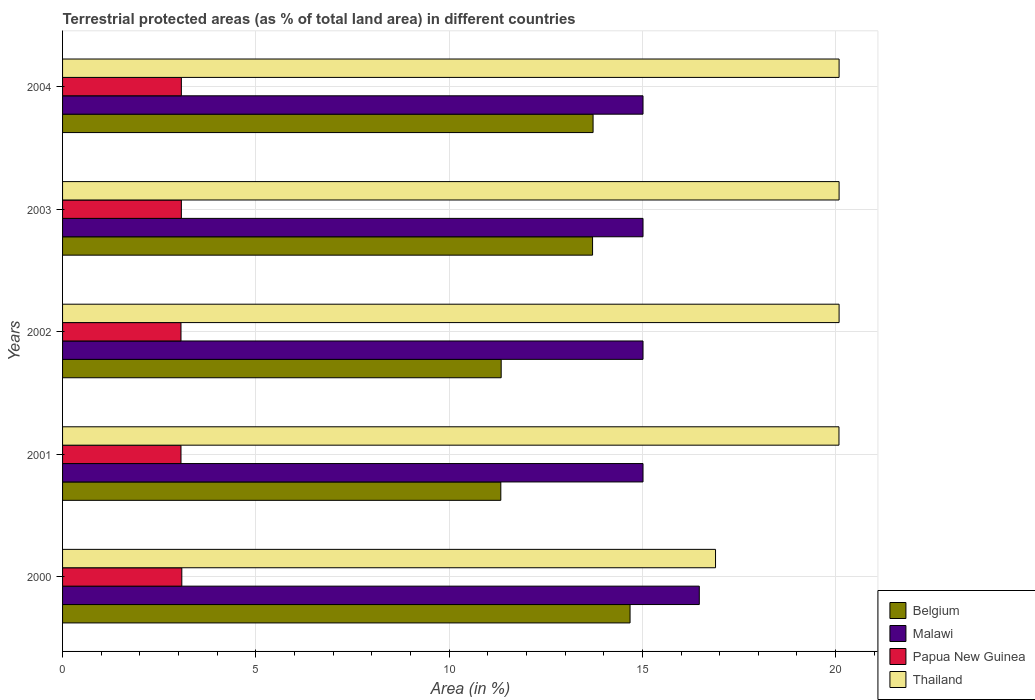How many bars are there on the 2nd tick from the bottom?
Your answer should be compact. 4. What is the label of the 2nd group of bars from the top?
Your answer should be very brief. 2003. In how many cases, is the number of bars for a given year not equal to the number of legend labels?
Keep it short and to the point. 0. What is the percentage of terrestrial protected land in Belgium in 2002?
Provide a succinct answer. 11.35. Across all years, what is the maximum percentage of terrestrial protected land in Thailand?
Your answer should be compact. 20.09. Across all years, what is the minimum percentage of terrestrial protected land in Papua New Guinea?
Give a very brief answer. 3.06. In which year was the percentage of terrestrial protected land in Thailand maximum?
Your answer should be compact. 2003. In which year was the percentage of terrestrial protected land in Papua New Guinea minimum?
Offer a terse response. 2001. What is the total percentage of terrestrial protected land in Papua New Guinea in the graph?
Provide a succinct answer. 15.36. What is the difference between the percentage of terrestrial protected land in Belgium in 2001 and that in 2003?
Provide a short and direct response. -2.37. What is the difference between the percentage of terrestrial protected land in Papua New Guinea in 2004 and the percentage of terrestrial protected land in Thailand in 2003?
Keep it short and to the point. -17.02. What is the average percentage of terrestrial protected land in Malawi per year?
Your response must be concise. 15.31. In the year 2004, what is the difference between the percentage of terrestrial protected land in Belgium and percentage of terrestrial protected land in Malawi?
Your answer should be compact. -1.29. In how many years, is the percentage of terrestrial protected land in Papua New Guinea greater than 10 %?
Keep it short and to the point. 0. What is the ratio of the percentage of terrestrial protected land in Malawi in 2000 to that in 2004?
Keep it short and to the point. 1.1. Is the percentage of terrestrial protected land in Thailand in 2001 less than that in 2003?
Provide a succinct answer. Yes. What is the difference between the highest and the second highest percentage of terrestrial protected land in Belgium?
Ensure brevity in your answer.  0.96. What is the difference between the highest and the lowest percentage of terrestrial protected land in Malawi?
Your answer should be compact. 1.46. Is it the case that in every year, the sum of the percentage of terrestrial protected land in Papua New Guinea and percentage of terrestrial protected land in Belgium is greater than the sum of percentage of terrestrial protected land in Thailand and percentage of terrestrial protected land in Malawi?
Provide a short and direct response. No. What does the 1st bar from the bottom in 2001 represents?
Give a very brief answer. Belgium. Are all the bars in the graph horizontal?
Your answer should be very brief. Yes. How many years are there in the graph?
Provide a succinct answer. 5. What is the difference between two consecutive major ticks on the X-axis?
Offer a very short reply. 5. Where does the legend appear in the graph?
Make the answer very short. Bottom right. How many legend labels are there?
Offer a terse response. 4. What is the title of the graph?
Give a very brief answer. Terrestrial protected areas (as % of total land area) in different countries. What is the label or title of the X-axis?
Your response must be concise. Area (in %). What is the Area (in %) in Belgium in 2000?
Keep it short and to the point. 14.68. What is the Area (in %) in Malawi in 2000?
Ensure brevity in your answer.  16.47. What is the Area (in %) in Papua New Guinea in 2000?
Keep it short and to the point. 3.09. What is the Area (in %) of Thailand in 2000?
Make the answer very short. 16.89. What is the Area (in %) of Belgium in 2001?
Ensure brevity in your answer.  11.34. What is the Area (in %) in Malawi in 2001?
Give a very brief answer. 15.02. What is the Area (in %) in Papua New Guinea in 2001?
Offer a terse response. 3.06. What is the Area (in %) of Thailand in 2001?
Keep it short and to the point. 20.09. What is the Area (in %) in Belgium in 2002?
Provide a succinct answer. 11.35. What is the Area (in %) of Malawi in 2002?
Offer a very short reply. 15.02. What is the Area (in %) of Papua New Guinea in 2002?
Your answer should be very brief. 3.06. What is the Area (in %) of Thailand in 2002?
Offer a very short reply. 20.09. What is the Area (in %) of Belgium in 2003?
Give a very brief answer. 13.71. What is the Area (in %) of Malawi in 2003?
Make the answer very short. 15.02. What is the Area (in %) of Papua New Guinea in 2003?
Keep it short and to the point. 3.07. What is the Area (in %) of Thailand in 2003?
Provide a succinct answer. 20.09. What is the Area (in %) in Belgium in 2004?
Your answer should be very brief. 13.73. What is the Area (in %) of Malawi in 2004?
Keep it short and to the point. 15.02. What is the Area (in %) in Papua New Guinea in 2004?
Make the answer very short. 3.07. What is the Area (in %) in Thailand in 2004?
Ensure brevity in your answer.  20.09. Across all years, what is the maximum Area (in %) of Belgium?
Offer a very short reply. 14.68. Across all years, what is the maximum Area (in %) in Malawi?
Ensure brevity in your answer.  16.47. Across all years, what is the maximum Area (in %) in Papua New Guinea?
Ensure brevity in your answer.  3.09. Across all years, what is the maximum Area (in %) of Thailand?
Ensure brevity in your answer.  20.09. Across all years, what is the minimum Area (in %) of Belgium?
Offer a very short reply. 11.34. Across all years, what is the minimum Area (in %) in Malawi?
Make the answer very short. 15.02. Across all years, what is the minimum Area (in %) in Papua New Guinea?
Offer a terse response. 3.06. Across all years, what is the minimum Area (in %) of Thailand?
Your answer should be compact. 16.89. What is the total Area (in %) of Belgium in the graph?
Provide a succinct answer. 64.81. What is the total Area (in %) of Malawi in the graph?
Make the answer very short. 76.54. What is the total Area (in %) of Papua New Guinea in the graph?
Ensure brevity in your answer.  15.36. What is the total Area (in %) of Thailand in the graph?
Make the answer very short. 97.25. What is the difference between the Area (in %) of Belgium in 2000 and that in 2001?
Keep it short and to the point. 3.34. What is the difference between the Area (in %) of Malawi in 2000 and that in 2001?
Give a very brief answer. 1.46. What is the difference between the Area (in %) of Papua New Guinea in 2000 and that in 2001?
Your answer should be very brief. 0.02. What is the difference between the Area (in %) of Thailand in 2000 and that in 2001?
Offer a very short reply. -3.19. What is the difference between the Area (in %) in Belgium in 2000 and that in 2002?
Give a very brief answer. 3.33. What is the difference between the Area (in %) in Malawi in 2000 and that in 2002?
Make the answer very short. 1.46. What is the difference between the Area (in %) of Papua New Guinea in 2000 and that in 2002?
Give a very brief answer. 0.02. What is the difference between the Area (in %) of Thailand in 2000 and that in 2002?
Give a very brief answer. -3.2. What is the difference between the Area (in %) in Belgium in 2000 and that in 2003?
Make the answer very short. 0.97. What is the difference between the Area (in %) in Malawi in 2000 and that in 2003?
Your response must be concise. 1.46. What is the difference between the Area (in %) of Papua New Guinea in 2000 and that in 2003?
Give a very brief answer. 0.01. What is the difference between the Area (in %) of Thailand in 2000 and that in 2003?
Give a very brief answer. -3.2. What is the difference between the Area (in %) of Belgium in 2000 and that in 2004?
Your answer should be very brief. 0.96. What is the difference between the Area (in %) in Malawi in 2000 and that in 2004?
Keep it short and to the point. 1.46. What is the difference between the Area (in %) in Papua New Guinea in 2000 and that in 2004?
Give a very brief answer. 0.01. What is the difference between the Area (in %) in Thailand in 2000 and that in 2004?
Your answer should be compact. -3.2. What is the difference between the Area (in %) in Belgium in 2001 and that in 2002?
Your response must be concise. -0.01. What is the difference between the Area (in %) in Papua New Guinea in 2001 and that in 2002?
Provide a succinct answer. 0. What is the difference between the Area (in %) in Thailand in 2001 and that in 2002?
Your answer should be compact. -0. What is the difference between the Area (in %) in Belgium in 2001 and that in 2003?
Your answer should be compact. -2.37. What is the difference between the Area (in %) in Papua New Guinea in 2001 and that in 2003?
Give a very brief answer. -0.01. What is the difference between the Area (in %) in Thailand in 2001 and that in 2003?
Give a very brief answer. -0. What is the difference between the Area (in %) of Belgium in 2001 and that in 2004?
Offer a very short reply. -2.39. What is the difference between the Area (in %) of Papua New Guinea in 2001 and that in 2004?
Keep it short and to the point. -0.01. What is the difference between the Area (in %) in Thailand in 2001 and that in 2004?
Ensure brevity in your answer.  -0. What is the difference between the Area (in %) in Belgium in 2002 and that in 2003?
Give a very brief answer. -2.36. What is the difference between the Area (in %) in Malawi in 2002 and that in 2003?
Keep it short and to the point. 0. What is the difference between the Area (in %) in Papua New Guinea in 2002 and that in 2003?
Offer a very short reply. -0.01. What is the difference between the Area (in %) of Belgium in 2002 and that in 2004?
Provide a succinct answer. -2.38. What is the difference between the Area (in %) in Papua New Guinea in 2002 and that in 2004?
Offer a terse response. -0.01. What is the difference between the Area (in %) in Belgium in 2003 and that in 2004?
Your answer should be very brief. -0.01. What is the difference between the Area (in %) of Belgium in 2000 and the Area (in %) of Malawi in 2001?
Offer a terse response. -0.34. What is the difference between the Area (in %) in Belgium in 2000 and the Area (in %) in Papua New Guinea in 2001?
Your answer should be very brief. 11.62. What is the difference between the Area (in %) in Belgium in 2000 and the Area (in %) in Thailand in 2001?
Make the answer very short. -5.4. What is the difference between the Area (in %) of Malawi in 2000 and the Area (in %) of Papua New Guinea in 2001?
Ensure brevity in your answer.  13.41. What is the difference between the Area (in %) of Malawi in 2000 and the Area (in %) of Thailand in 2001?
Your answer should be very brief. -3.61. What is the difference between the Area (in %) of Papua New Guinea in 2000 and the Area (in %) of Thailand in 2001?
Give a very brief answer. -17. What is the difference between the Area (in %) of Belgium in 2000 and the Area (in %) of Malawi in 2002?
Make the answer very short. -0.34. What is the difference between the Area (in %) of Belgium in 2000 and the Area (in %) of Papua New Guinea in 2002?
Offer a terse response. 11.62. What is the difference between the Area (in %) of Belgium in 2000 and the Area (in %) of Thailand in 2002?
Make the answer very short. -5.41. What is the difference between the Area (in %) of Malawi in 2000 and the Area (in %) of Papua New Guinea in 2002?
Your answer should be compact. 13.41. What is the difference between the Area (in %) of Malawi in 2000 and the Area (in %) of Thailand in 2002?
Offer a very short reply. -3.62. What is the difference between the Area (in %) of Papua New Guinea in 2000 and the Area (in %) of Thailand in 2002?
Keep it short and to the point. -17. What is the difference between the Area (in %) of Belgium in 2000 and the Area (in %) of Malawi in 2003?
Your response must be concise. -0.34. What is the difference between the Area (in %) of Belgium in 2000 and the Area (in %) of Papua New Guinea in 2003?
Keep it short and to the point. 11.61. What is the difference between the Area (in %) of Belgium in 2000 and the Area (in %) of Thailand in 2003?
Offer a very short reply. -5.41. What is the difference between the Area (in %) in Malawi in 2000 and the Area (in %) in Thailand in 2003?
Provide a succinct answer. -3.62. What is the difference between the Area (in %) of Papua New Guinea in 2000 and the Area (in %) of Thailand in 2003?
Your answer should be compact. -17. What is the difference between the Area (in %) in Belgium in 2000 and the Area (in %) in Malawi in 2004?
Give a very brief answer. -0.34. What is the difference between the Area (in %) in Belgium in 2000 and the Area (in %) in Papua New Guinea in 2004?
Offer a very short reply. 11.61. What is the difference between the Area (in %) of Belgium in 2000 and the Area (in %) of Thailand in 2004?
Your answer should be very brief. -5.41. What is the difference between the Area (in %) in Malawi in 2000 and the Area (in %) in Papua New Guinea in 2004?
Your answer should be compact. 13.4. What is the difference between the Area (in %) in Malawi in 2000 and the Area (in %) in Thailand in 2004?
Your answer should be very brief. -3.62. What is the difference between the Area (in %) in Papua New Guinea in 2000 and the Area (in %) in Thailand in 2004?
Offer a very short reply. -17. What is the difference between the Area (in %) of Belgium in 2001 and the Area (in %) of Malawi in 2002?
Your answer should be very brief. -3.68. What is the difference between the Area (in %) of Belgium in 2001 and the Area (in %) of Papua New Guinea in 2002?
Ensure brevity in your answer.  8.27. What is the difference between the Area (in %) in Belgium in 2001 and the Area (in %) in Thailand in 2002?
Provide a succinct answer. -8.75. What is the difference between the Area (in %) of Malawi in 2001 and the Area (in %) of Papua New Guinea in 2002?
Keep it short and to the point. 11.95. What is the difference between the Area (in %) in Malawi in 2001 and the Area (in %) in Thailand in 2002?
Ensure brevity in your answer.  -5.07. What is the difference between the Area (in %) of Papua New Guinea in 2001 and the Area (in %) of Thailand in 2002?
Offer a terse response. -17.03. What is the difference between the Area (in %) in Belgium in 2001 and the Area (in %) in Malawi in 2003?
Provide a short and direct response. -3.68. What is the difference between the Area (in %) of Belgium in 2001 and the Area (in %) of Papua New Guinea in 2003?
Offer a terse response. 8.26. What is the difference between the Area (in %) in Belgium in 2001 and the Area (in %) in Thailand in 2003?
Provide a short and direct response. -8.75. What is the difference between the Area (in %) in Malawi in 2001 and the Area (in %) in Papua New Guinea in 2003?
Your answer should be compact. 11.94. What is the difference between the Area (in %) in Malawi in 2001 and the Area (in %) in Thailand in 2003?
Provide a succinct answer. -5.07. What is the difference between the Area (in %) of Papua New Guinea in 2001 and the Area (in %) of Thailand in 2003?
Ensure brevity in your answer.  -17.03. What is the difference between the Area (in %) in Belgium in 2001 and the Area (in %) in Malawi in 2004?
Provide a succinct answer. -3.68. What is the difference between the Area (in %) of Belgium in 2001 and the Area (in %) of Papua New Guinea in 2004?
Ensure brevity in your answer.  8.26. What is the difference between the Area (in %) in Belgium in 2001 and the Area (in %) in Thailand in 2004?
Your answer should be very brief. -8.75. What is the difference between the Area (in %) of Malawi in 2001 and the Area (in %) of Papua New Guinea in 2004?
Provide a short and direct response. 11.94. What is the difference between the Area (in %) of Malawi in 2001 and the Area (in %) of Thailand in 2004?
Your answer should be compact. -5.07. What is the difference between the Area (in %) of Papua New Guinea in 2001 and the Area (in %) of Thailand in 2004?
Your answer should be compact. -17.03. What is the difference between the Area (in %) in Belgium in 2002 and the Area (in %) in Malawi in 2003?
Provide a succinct answer. -3.67. What is the difference between the Area (in %) of Belgium in 2002 and the Area (in %) of Papua New Guinea in 2003?
Keep it short and to the point. 8.27. What is the difference between the Area (in %) in Belgium in 2002 and the Area (in %) in Thailand in 2003?
Your response must be concise. -8.74. What is the difference between the Area (in %) in Malawi in 2002 and the Area (in %) in Papua New Guinea in 2003?
Provide a short and direct response. 11.94. What is the difference between the Area (in %) in Malawi in 2002 and the Area (in %) in Thailand in 2003?
Keep it short and to the point. -5.07. What is the difference between the Area (in %) of Papua New Guinea in 2002 and the Area (in %) of Thailand in 2003?
Provide a short and direct response. -17.03. What is the difference between the Area (in %) of Belgium in 2002 and the Area (in %) of Malawi in 2004?
Offer a terse response. -3.67. What is the difference between the Area (in %) of Belgium in 2002 and the Area (in %) of Papua New Guinea in 2004?
Provide a short and direct response. 8.27. What is the difference between the Area (in %) of Belgium in 2002 and the Area (in %) of Thailand in 2004?
Give a very brief answer. -8.74. What is the difference between the Area (in %) in Malawi in 2002 and the Area (in %) in Papua New Guinea in 2004?
Your answer should be very brief. 11.94. What is the difference between the Area (in %) in Malawi in 2002 and the Area (in %) in Thailand in 2004?
Offer a terse response. -5.07. What is the difference between the Area (in %) in Papua New Guinea in 2002 and the Area (in %) in Thailand in 2004?
Provide a succinct answer. -17.03. What is the difference between the Area (in %) of Belgium in 2003 and the Area (in %) of Malawi in 2004?
Provide a succinct answer. -1.31. What is the difference between the Area (in %) in Belgium in 2003 and the Area (in %) in Papua New Guinea in 2004?
Provide a short and direct response. 10.64. What is the difference between the Area (in %) of Belgium in 2003 and the Area (in %) of Thailand in 2004?
Your answer should be very brief. -6.38. What is the difference between the Area (in %) in Malawi in 2003 and the Area (in %) in Papua New Guinea in 2004?
Make the answer very short. 11.94. What is the difference between the Area (in %) in Malawi in 2003 and the Area (in %) in Thailand in 2004?
Keep it short and to the point. -5.07. What is the difference between the Area (in %) of Papua New Guinea in 2003 and the Area (in %) of Thailand in 2004?
Make the answer very short. -17.02. What is the average Area (in %) of Belgium per year?
Provide a succinct answer. 12.96. What is the average Area (in %) of Malawi per year?
Provide a short and direct response. 15.31. What is the average Area (in %) in Papua New Guinea per year?
Make the answer very short. 3.07. What is the average Area (in %) of Thailand per year?
Provide a short and direct response. 19.45. In the year 2000, what is the difference between the Area (in %) of Belgium and Area (in %) of Malawi?
Your response must be concise. -1.79. In the year 2000, what is the difference between the Area (in %) of Belgium and Area (in %) of Papua New Guinea?
Your response must be concise. 11.6. In the year 2000, what is the difference between the Area (in %) in Belgium and Area (in %) in Thailand?
Provide a succinct answer. -2.21. In the year 2000, what is the difference between the Area (in %) in Malawi and Area (in %) in Papua New Guinea?
Offer a terse response. 13.39. In the year 2000, what is the difference between the Area (in %) in Malawi and Area (in %) in Thailand?
Your answer should be compact. -0.42. In the year 2000, what is the difference between the Area (in %) in Papua New Guinea and Area (in %) in Thailand?
Your answer should be compact. -13.81. In the year 2001, what is the difference between the Area (in %) of Belgium and Area (in %) of Malawi?
Offer a terse response. -3.68. In the year 2001, what is the difference between the Area (in %) of Belgium and Area (in %) of Papua New Guinea?
Your response must be concise. 8.27. In the year 2001, what is the difference between the Area (in %) of Belgium and Area (in %) of Thailand?
Ensure brevity in your answer.  -8.75. In the year 2001, what is the difference between the Area (in %) of Malawi and Area (in %) of Papua New Guinea?
Provide a short and direct response. 11.95. In the year 2001, what is the difference between the Area (in %) of Malawi and Area (in %) of Thailand?
Offer a terse response. -5.07. In the year 2001, what is the difference between the Area (in %) of Papua New Guinea and Area (in %) of Thailand?
Keep it short and to the point. -17.02. In the year 2002, what is the difference between the Area (in %) of Belgium and Area (in %) of Malawi?
Make the answer very short. -3.67. In the year 2002, what is the difference between the Area (in %) of Belgium and Area (in %) of Papua New Guinea?
Provide a short and direct response. 8.28. In the year 2002, what is the difference between the Area (in %) of Belgium and Area (in %) of Thailand?
Give a very brief answer. -8.74. In the year 2002, what is the difference between the Area (in %) of Malawi and Area (in %) of Papua New Guinea?
Provide a short and direct response. 11.95. In the year 2002, what is the difference between the Area (in %) in Malawi and Area (in %) in Thailand?
Give a very brief answer. -5.07. In the year 2002, what is the difference between the Area (in %) of Papua New Guinea and Area (in %) of Thailand?
Ensure brevity in your answer.  -17.03. In the year 2003, what is the difference between the Area (in %) in Belgium and Area (in %) in Malawi?
Your answer should be compact. -1.31. In the year 2003, what is the difference between the Area (in %) in Belgium and Area (in %) in Papua New Guinea?
Offer a terse response. 10.64. In the year 2003, what is the difference between the Area (in %) in Belgium and Area (in %) in Thailand?
Your answer should be compact. -6.38. In the year 2003, what is the difference between the Area (in %) in Malawi and Area (in %) in Papua New Guinea?
Your answer should be very brief. 11.94. In the year 2003, what is the difference between the Area (in %) of Malawi and Area (in %) of Thailand?
Ensure brevity in your answer.  -5.07. In the year 2003, what is the difference between the Area (in %) in Papua New Guinea and Area (in %) in Thailand?
Provide a succinct answer. -17.02. In the year 2004, what is the difference between the Area (in %) in Belgium and Area (in %) in Malawi?
Offer a very short reply. -1.29. In the year 2004, what is the difference between the Area (in %) in Belgium and Area (in %) in Papua New Guinea?
Provide a short and direct response. 10.65. In the year 2004, what is the difference between the Area (in %) of Belgium and Area (in %) of Thailand?
Give a very brief answer. -6.36. In the year 2004, what is the difference between the Area (in %) of Malawi and Area (in %) of Papua New Guinea?
Give a very brief answer. 11.94. In the year 2004, what is the difference between the Area (in %) of Malawi and Area (in %) of Thailand?
Your response must be concise. -5.07. In the year 2004, what is the difference between the Area (in %) in Papua New Guinea and Area (in %) in Thailand?
Your answer should be compact. -17.02. What is the ratio of the Area (in %) in Belgium in 2000 to that in 2001?
Provide a succinct answer. 1.29. What is the ratio of the Area (in %) in Malawi in 2000 to that in 2001?
Your answer should be compact. 1.1. What is the ratio of the Area (in %) of Thailand in 2000 to that in 2001?
Give a very brief answer. 0.84. What is the ratio of the Area (in %) of Belgium in 2000 to that in 2002?
Your answer should be very brief. 1.29. What is the ratio of the Area (in %) in Malawi in 2000 to that in 2002?
Your response must be concise. 1.1. What is the ratio of the Area (in %) in Thailand in 2000 to that in 2002?
Provide a short and direct response. 0.84. What is the ratio of the Area (in %) of Belgium in 2000 to that in 2003?
Your response must be concise. 1.07. What is the ratio of the Area (in %) of Malawi in 2000 to that in 2003?
Your answer should be very brief. 1.1. What is the ratio of the Area (in %) in Thailand in 2000 to that in 2003?
Provide a succinct answer. 0.84. What is the ratio of the Area (in %) in Belgium in 2000 to that in 2004?
Give a very brief answer. 1.07. What is the ratio of the Area (in %) of Malawi in 2000 to that in 2004?
Provide a succinct answer. 1.1. What is the ratio of the Area (in %) of Thailand in 2000 to that in 2004?
Offer a very short reply. 0.84. What is the ratio of the Area (in %) of Malawi in 2001 to that in 2002?
Provide a succinct answer. 1. What is the ratio of the Area (in %) in Thailand in 2001 to that in 2002?
Make the answer very short. 1. What is the ratio of the Area (in %) in Belgium in 2001 to that in 2003?
Your response must be concise. 0.83. What is the ratio of the Area (in %) in Malawi in 2001 to that in 2003?
Offer a terse response. 1. What is the ratio of the Area (in %) of Thailand in 2001 to that in 2003?
Ensure brevity in your answer.  1. What is the ratio of the Area (in %) of Belgium in 2001 to that in 2004?
Your answer should be very brief. 0.83. What is the ratio of the Area (in %) in Malawi in 2001 to that in 2004?
Offer a terse response. 1. What is the ratio of the Area (in %) of Papua New Guinea in 2001 to that in 2004?
Provide a succinct answer. 1. What is the ratio of the Area (in %) in Belgium in 2002 to that in 2003?
Give a very brief answer. 0.83. What is the ratio of the Area (in %) of Malawi in 2002 to that in 2003?
Provide a succinct answer. 1. What is the ratio of the Area (in %) of Thailand in 2002 to that in 2003?
Keep it short and to the point. 1. What is the ratio of the Area (in %) of Belgium in 2002 to that in 2004?
Your answer should be compact. 0.83. What is the ratio of the Area (in %) of Belgium in 2003 to that in 2004?
Your response must be concise. 1. What is the ratio of the Area (in %) of Malawi in 2003 to that in 2004?
Your response must be concise. 1. What is the ratio of the Area (in %) of Thailand in 2003 to that in 2004?
Offer a terse response. 1. What is the difference between the highest and the second highest Area (in %) in Belgium?
Your answer should be very brief. 0.96. What is the difference between the highest and the second highest Area (in %) of Malawi?
Give a very brief answer. 1.46. What is the difference between the highest and the second highest Area (in %) in Papua New Guinea?
Your answer should be very brief. 0.01. What is the difference between the highest and the second highest Area (in %) in Thailand?
Give a very brief answer. 0. What is the difference between the highest and the lowest Area (in %) in Belgium?
Keep it short and to the point. 3.34. What is the difference between the highest and the lowest Area (in %) in Malawi?
Your answer should be very brief. 1.46. What is the difference between the highest and the lowest Area (in %) of Papua New Guinea?
Make the answer very short. 0.02. What is the difference between the highest and the lowest Area (in %) of Thailand?
Your answer should be compact. 3.2. 